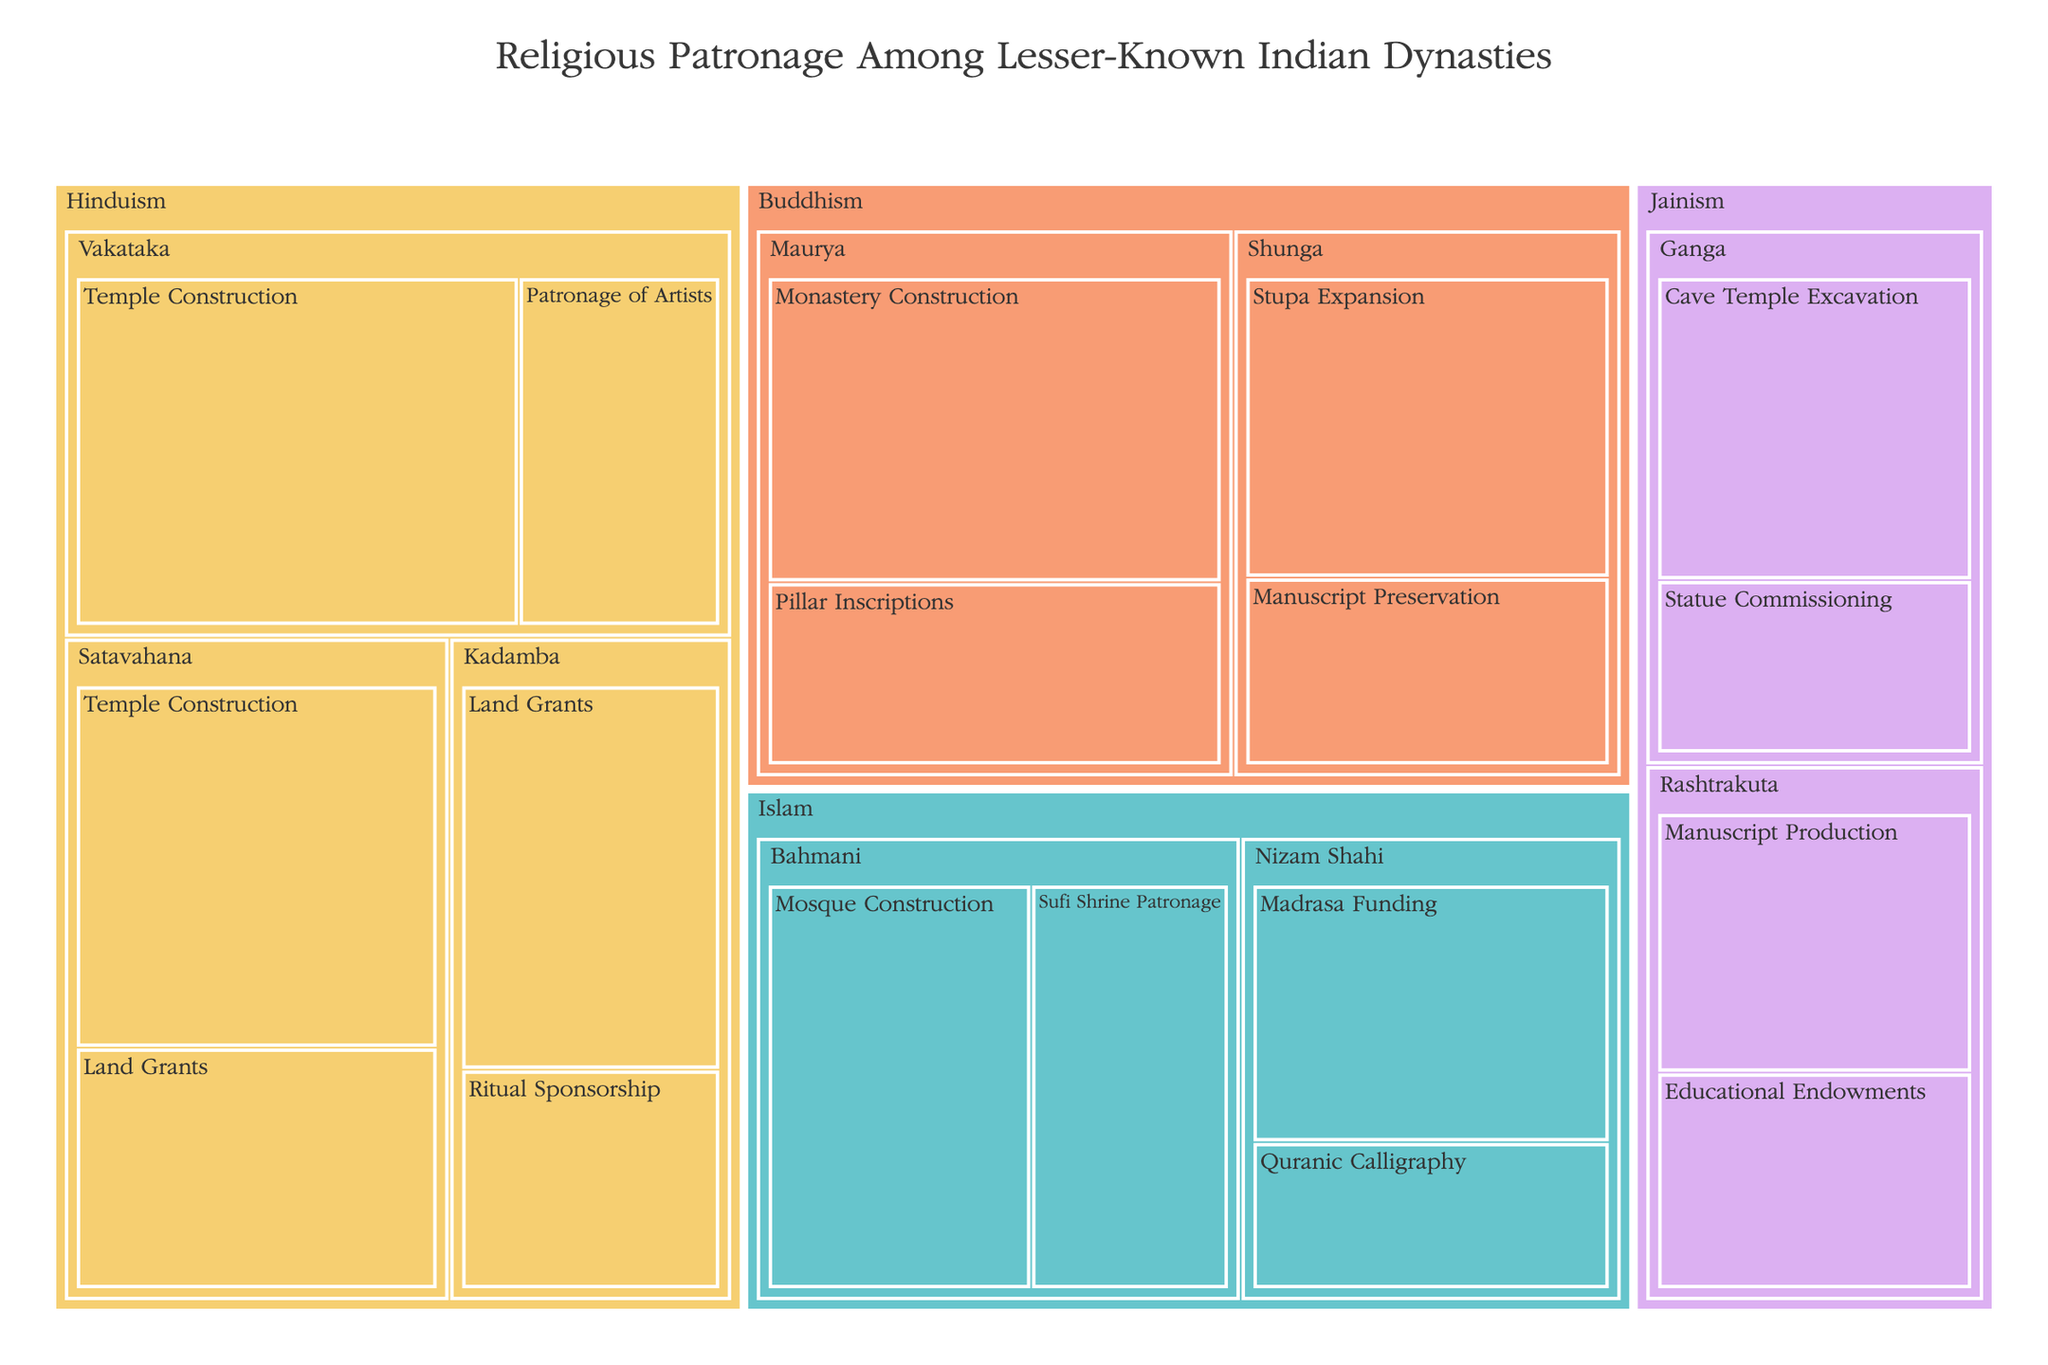What is the title of the figure? The title of the figure is prominently displayed at the top of the Treemap. This provides an immediate overview of the content of the visual.
Answer: Religious Patronage Among Lesser-Known Indian Dynasties Which faith received the highest total value of patronage? To determine this, sum up the individual values of support for each faith. Hinduism: 45+30+55+25+35+20=210, Buddhism: 50+30+40+25=145, Jainism: 35+20+30+25=110, Islam: 40+30+35+20=125. Therefore, Hinduism has the highest total value.
Answer: Hinduism How many forms of support are represented for Islam? Check the subcategories of the category "Islam" in the Treemap. The forms of support listed under Islam are Mosque Construction, Sufi Shrine Patronage, Madrasa Funding, and Quranic Calligraphy.
Answer: Four Which dynasty provided the highest value of support for Stupa Expansion in Buddhism? Locate "Buddhism" in the Treemap, then look for the subcategory "Stupa Expansion." Check the dynasty associated with this form of support and its value.
Answer: Shunga What is the difference in value between Land Grants under the Satavahana and Kadamba dynasties for Hinduism? Locate both "Satavahana" and "Kadamba" under the "Hinduism" category, then find the values for "Land Grants." The Satavahana dynasty has 30 and the Kadamba dynasty has 35. The difference is 35-30.
Answer: 5 Out of the patronage forms under Jainism, which received the smallest value of support and from which dynasty? Identify the forms of support under "Jainism" and compare their values. Cave Temple Excavation has 35, Statue Commissioning has 20, Manuscript Production has 30, and Educational Endowments have 25.
Answer: Statue Commissioning by the Ganga dynasty Compare the values between Manuscript Preservation in Buddhism and Quranic Calligraphy in Islam. Which has a higher value and by how much? Locate both "Manuscript Preservation" under Buddhism and "Quranic Calligraphy" under Islam in the Treemap, then compare their values. Manuscript Preservation has 25 and Quranic Calligraphy has 20. The difference is 25-20.
Answer: Manuscript Preservation has a higher value by 5 What is the average value of all forms of support under the Vakataka dynasty in Hinduism? Identify all the forms of support under the "Vakataka" dynasty: Temple Construction (55) and Patronage of Artists (25). Calculate their average: (55+25)/2.
Answer: 40 Which form of support under the Bahmani dynasty for Islam received more patronage, Mosque Construction or Sufi Shrine Patronage? Locate the Bahmani dynasty under "Islam" and check the values for Mosque Construction and Sufi Shrine Patronage. Mosque Construction has 40 and Sufi Shrine Patronage has 30.
Answer: Mosque Construction 